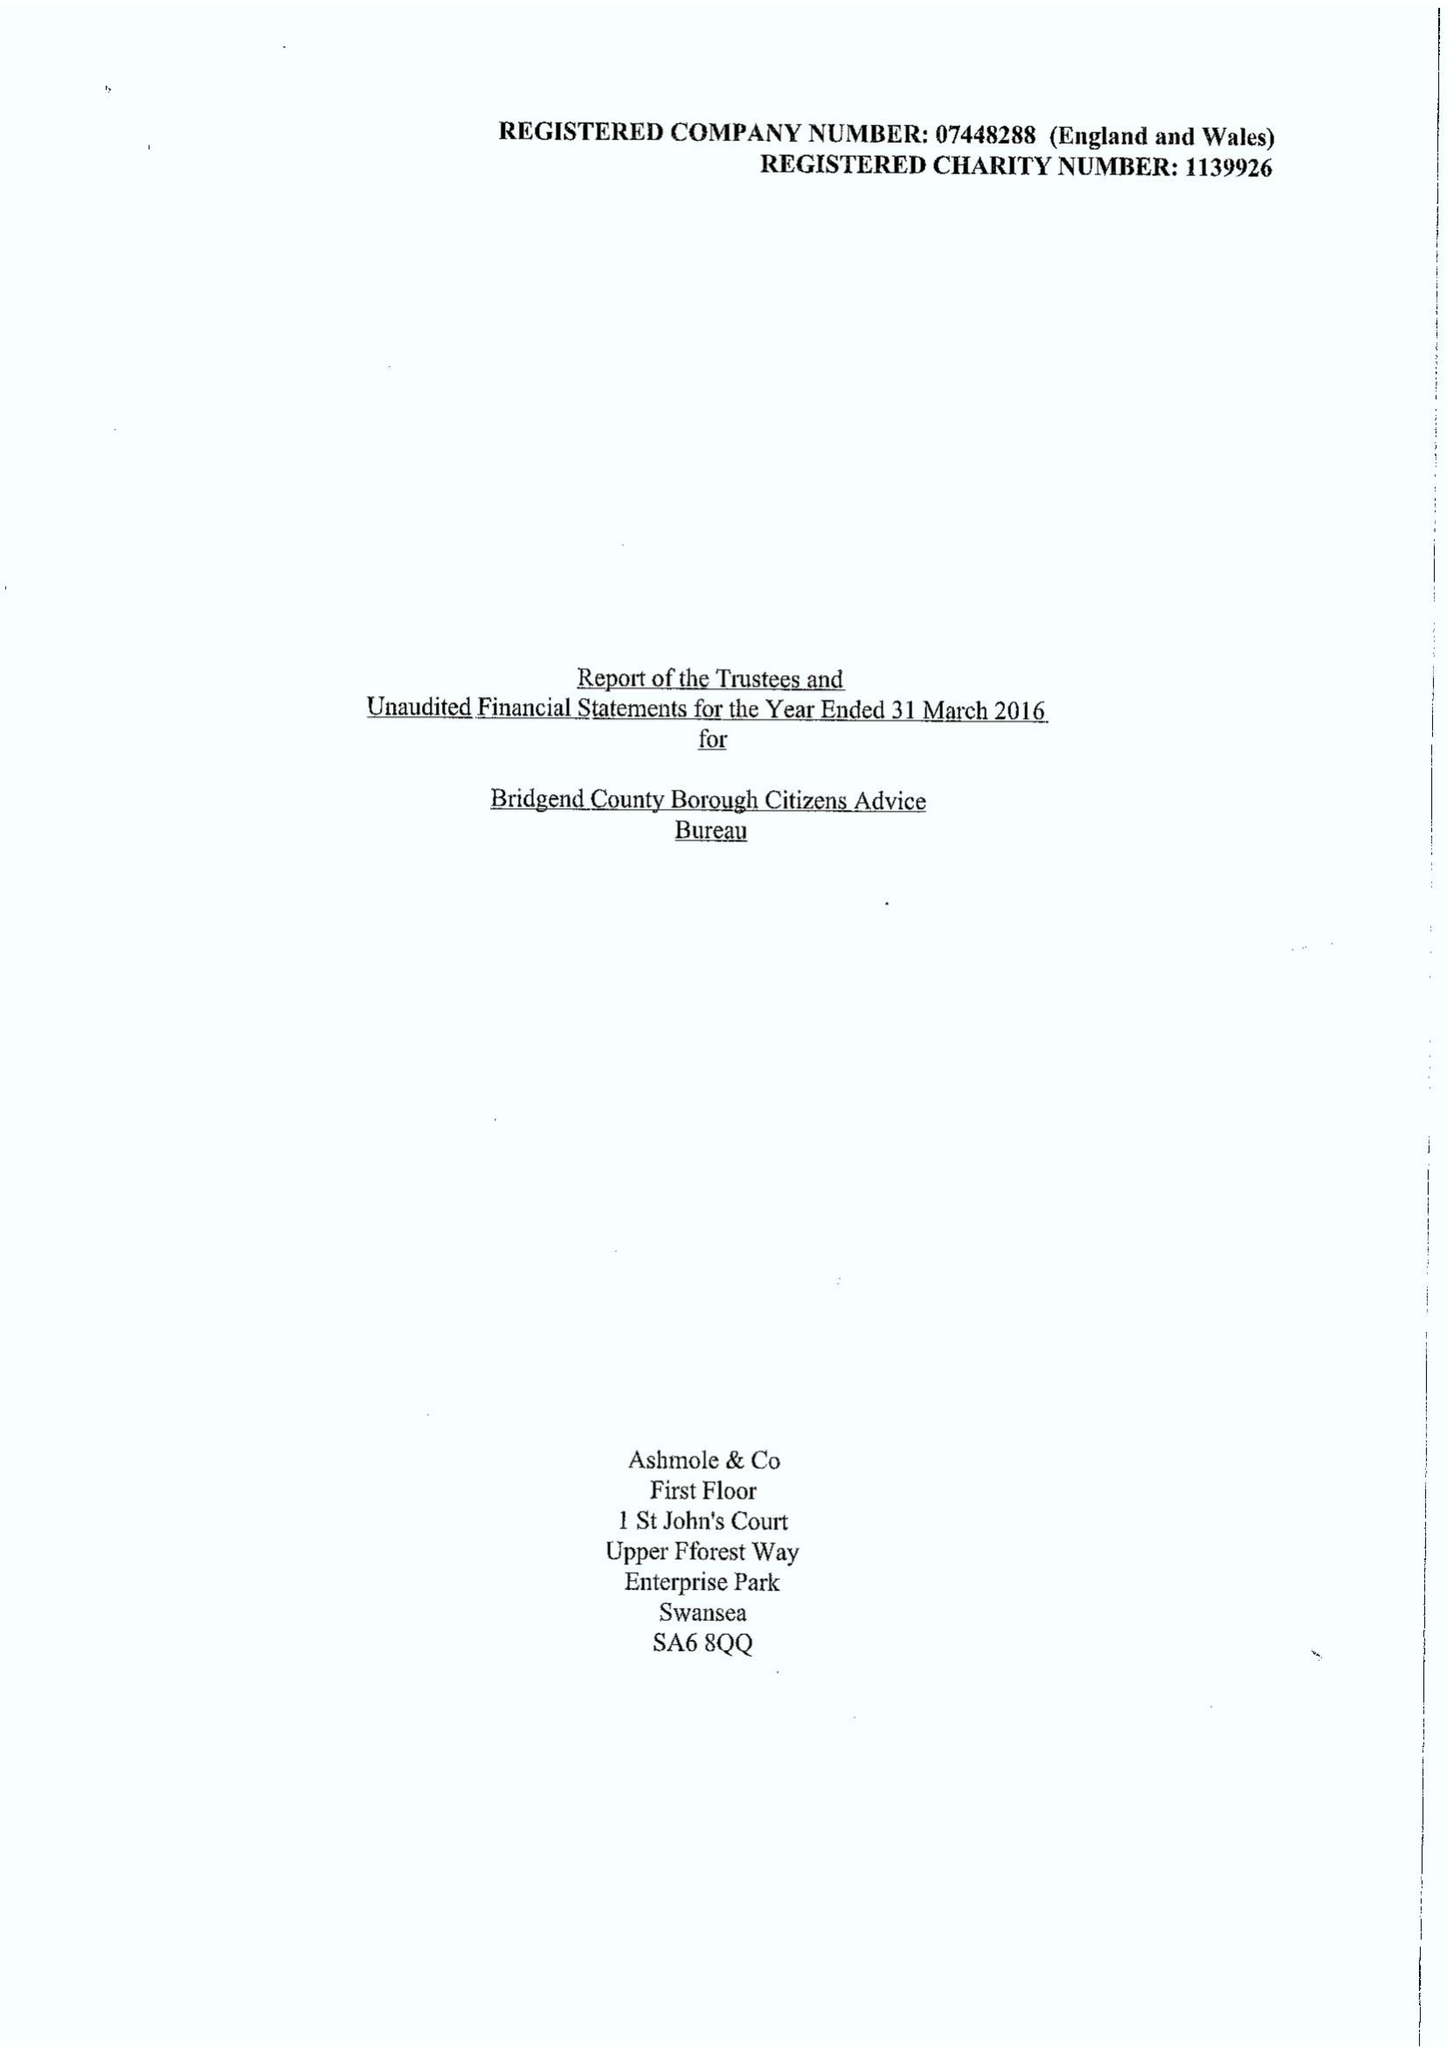What is the value for the address__post_town?
Answer the question using a single word or phrase. BRIDGEND 